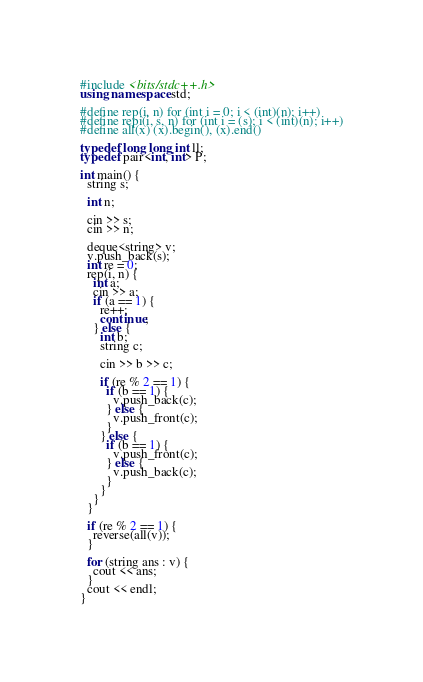<code> <loc_0><loc_0><loc_500><loc_500><_C++_>#include <bits/stdc++.h>
using namespace std;

#define rep(i, n) for (int i = 0; i < (int)(n); i++)
#define repi(i, s, n) for (int i = (s); i < (int)(n); i++)
#define all(x) (x).begin(), (x).end()

typedef long long int ll;
typedef pair<int, int> P;

int main() {
  string s;

  int n;

  cin >> s;
  cin >> n;

  deque<string> v;
  v.push_back(s);
  int re = 0;
  rep(i, n) {
    int a;
    cin >> a;
    if (a == 1) {
      re++;
      continue;
    } else {
      int b;
      string c;

      cin >> b >> c;

      if (re % 2 == 1) {
        if (b == 1) {
          v.push_back(c);
        } else {
          v.push_front(c);
        }
      } else {
        if (b == 1) {
          v.push_front(c);
        } else {
          v.push_back(c);
        }
      }
    }
  }

  if (re % 2 == 1) {
    reverse(all(v));
  }

  for (string ans : v) {
    cout << ans;
  }
  cout << endl;
}</code> 